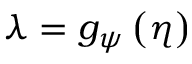Convert formula to latex. <formula><loc_0><loc_0><loc_500><loc_500>\lambda = g _ { \psi } \left ( \eta \right )</formula> 